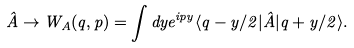<formula> <loc_0><loc_0><loc_500><loc_500>\hat { A } \rightarrow W _ { A } ( q , p ) = \int d y e ^ { i p y } \langle q - y / 2 | \hat { A } | q + y / 2 \rangle .</formula> 